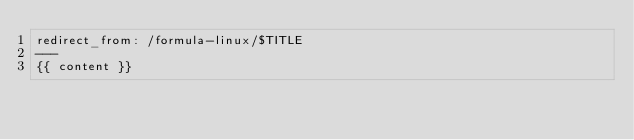<code> <loc_0><loc_0><loc_500><loc_500><_HTML_>redirect_from: /formula-linux/$TITLE
---
{{ content }}
</code> 